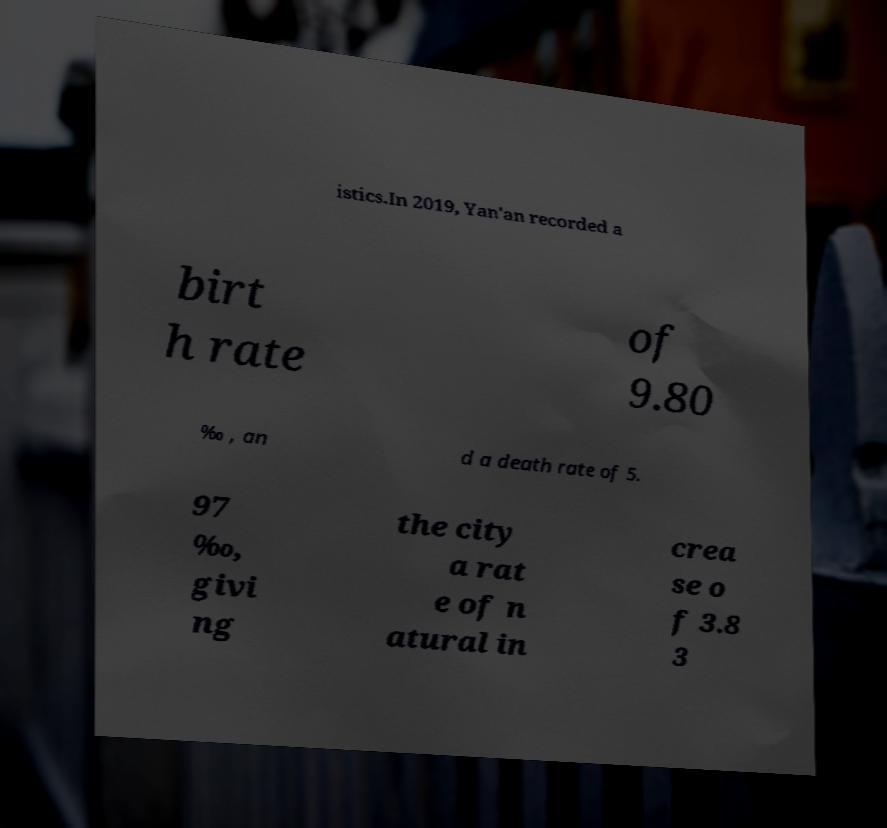Could you assist in decoding the text presented in this image and type it out clearly? istics.In 2019, Yan'an recorded a birt h rate of 9.80 ‰ , an d a death rate of 5. 97 ‰, givi ng the city a rat e of n atural in crea se o f 3.8 3 